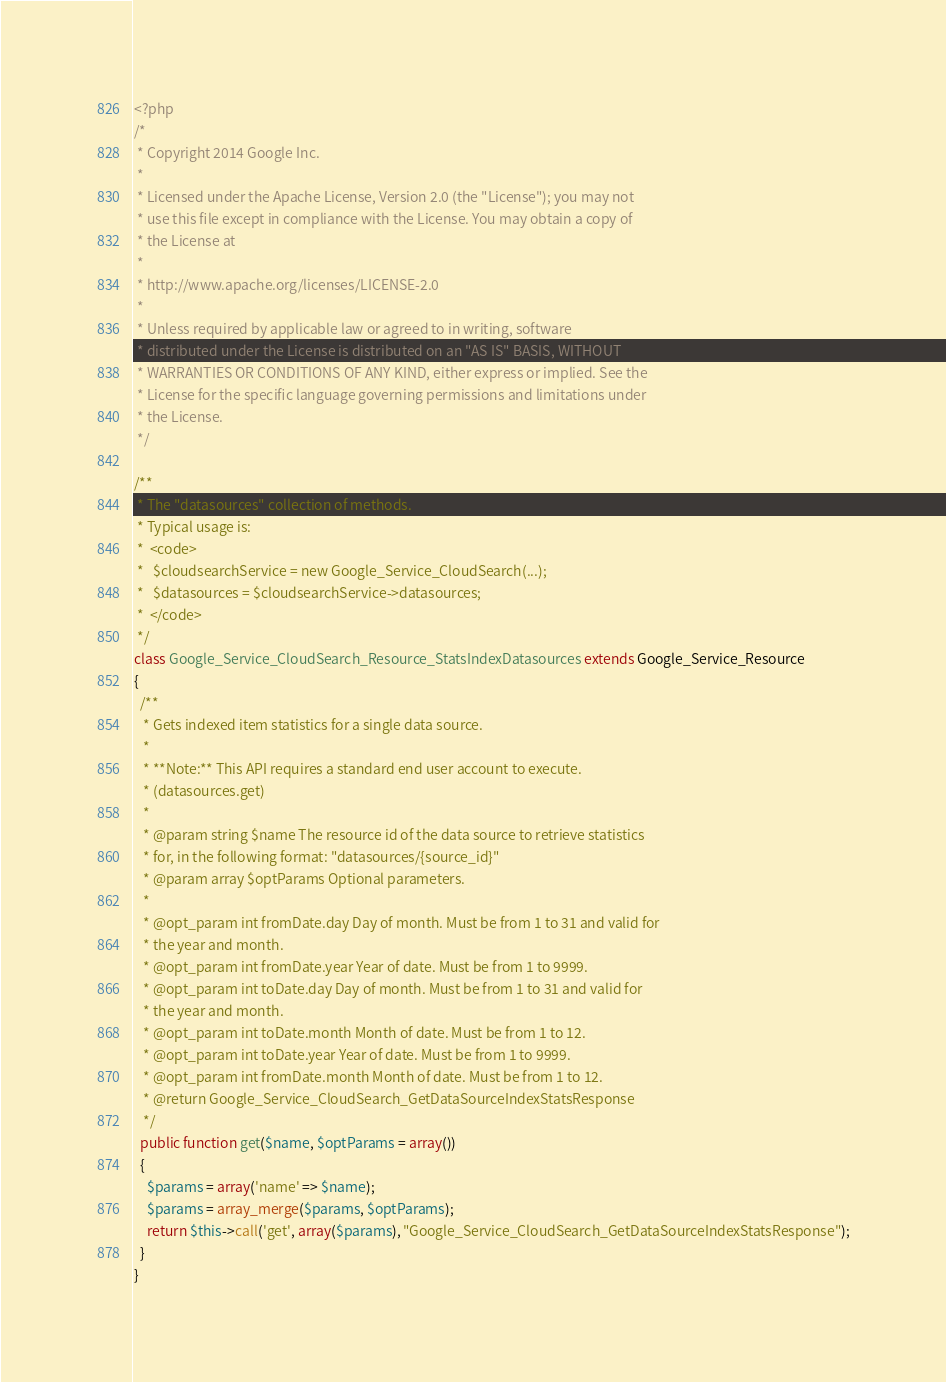Convert code to text. <code><loc_0><loc_0><loc_500><loc_500><_PHP_><?php
/*
 * Copyright 2014 Google Inc.
 *
 * Licensed under the Apache License, Version 2.0 (the "License"); you may not
 * use this file except in compliance with the License. You may obtain a copy of
 * the License at
 *
 * http://www.apache.org/licenses/LICENSE-2.0
 *
 * Unless required by applicable law or agreed to in writing, software
 * distributed under the License is distributed on an "AS IS" BASIS, WITHOUT
 * WARRANTIES OR CONDITIONS OF ANY KIND, either express or implied. See the
 * License for the specific language governing permissions and limitations under
 * the License.
 */

/**
 * The "datasources" collection of methods.
 * Typical usage is:
 *  <code>
 *   $cloudsearchService = new Google_Service_CloudSearch(...);
 *   $datasources = $cloudsearchService->datasources;
 *  </code>
 */
class Google_Service_CloudSearch_Resource_StatsIndexDatasources extends Google_Service_Resource
{
  /**
   * Gets indexed item statistics for a single data source.
   *
   * **Note:** This API requires a standard end user account to execute.
   * (datasources.get)
   *
   * @param string $name The resource id of the data source to retrieve statistics
   * for, in the following format: "datasources/{source_id}"
   * @param array $optParams Optional parameters.
   *
   * @opt_param int fromDate.day Day of month. Must be from 1 to 31 and valid for
   * the year and month.
   * @opt_param int fromDate.year Year of date. Must be from 1 to 9999.
   * @opt_param int toDate.day Day of month. Must be from 1 to 31 and valid for
   * the year and month.
   * @opt_param int toDate.month Month of date. Must be from 1 to 12.
   * @opt_param int toDate.year Year of date. Must be from 1 to 9999.
   * @opt_param int fromDate.month Month of date. Must be from 1 to 12.
   * @return Google_Service_CloudSearch_GetDataSourceIndexStatsResponse
   */
  public function get($name, $optParams = array())
  {
    $params = array('name' => $name);
    $params = array_merge($params, $optParams);
    return $this->call('get', array($params), "Google_Service_CloudSearch_GetDataSourceIndexStatsResponse");
  }
}
</code> 